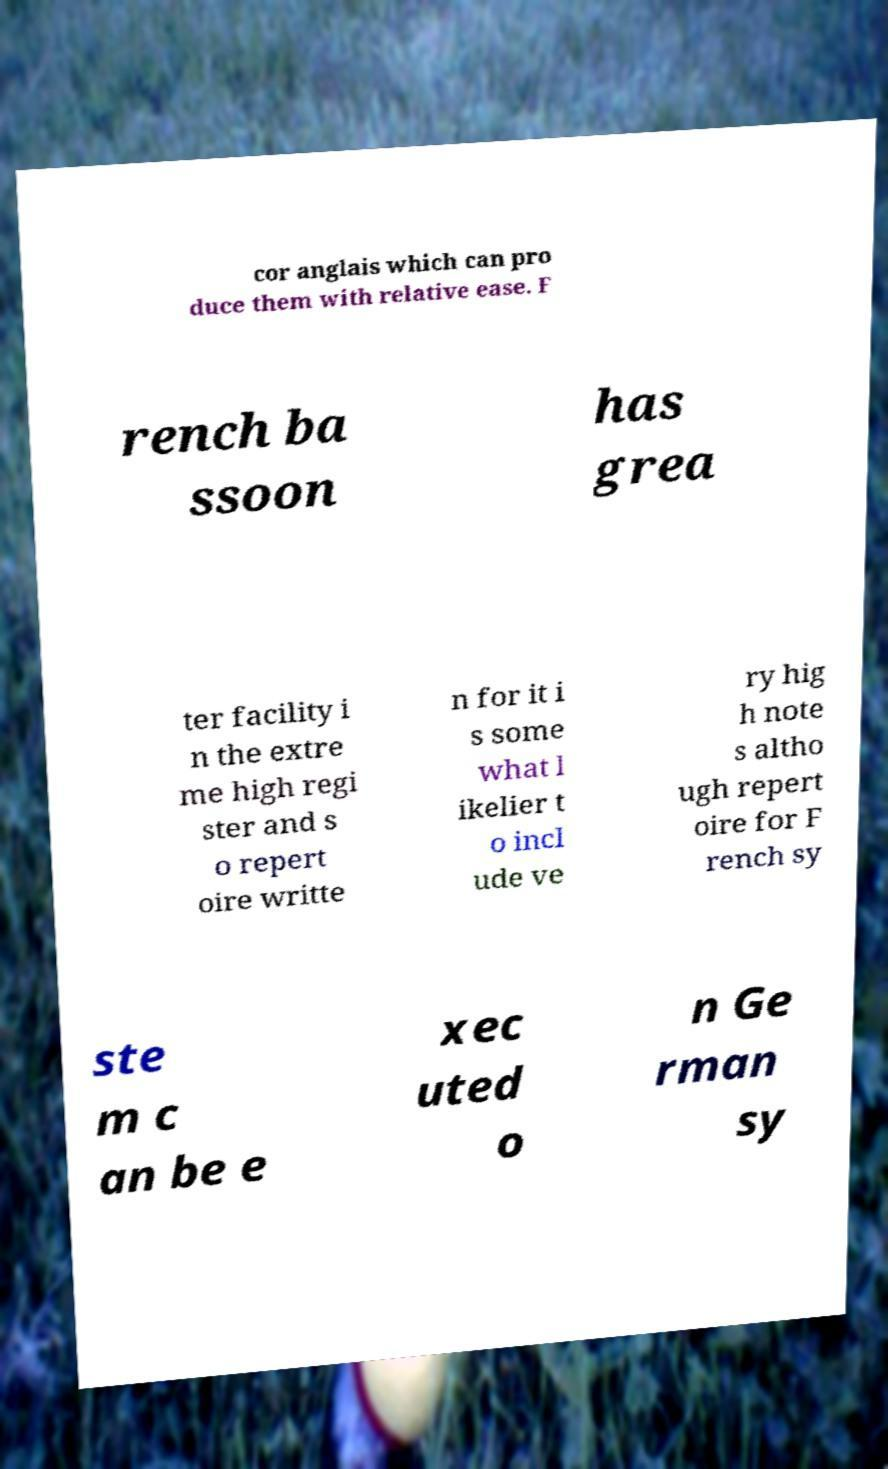There's text embedded in this image that I need extracted. Can you transcribe it verbatim? cor anglais which can pro duce them with relative ease. F rench ba ssoon has grea ter facility i n the extre me high regi ster and s o repert oire writte n for it i s some what l ikelier t o incl ude ve ry hig h note s altho ugh repert oire for F rench sy ste m c an be e xec uted o n Ge rman sy 